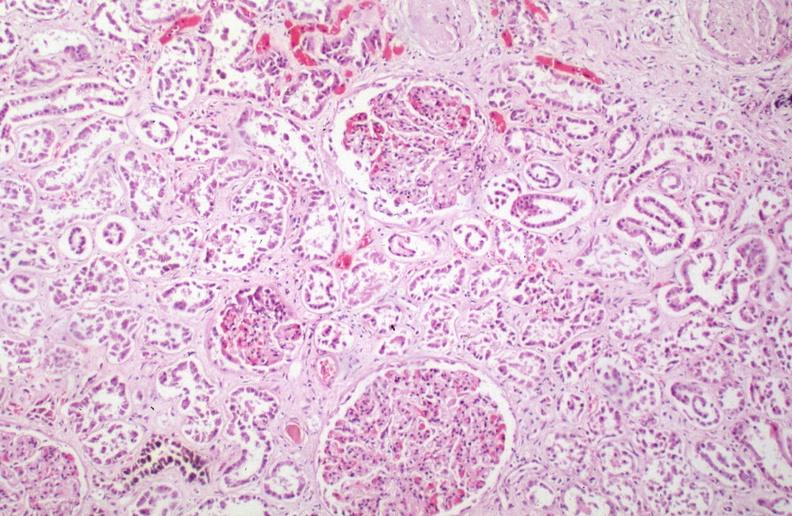where is this?
Answer the question using a single word or phrase. Urinary 